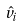<formula> <loc_0><loc_0><loc_500><loc_500>\hat { v } _ { i }</formula> 